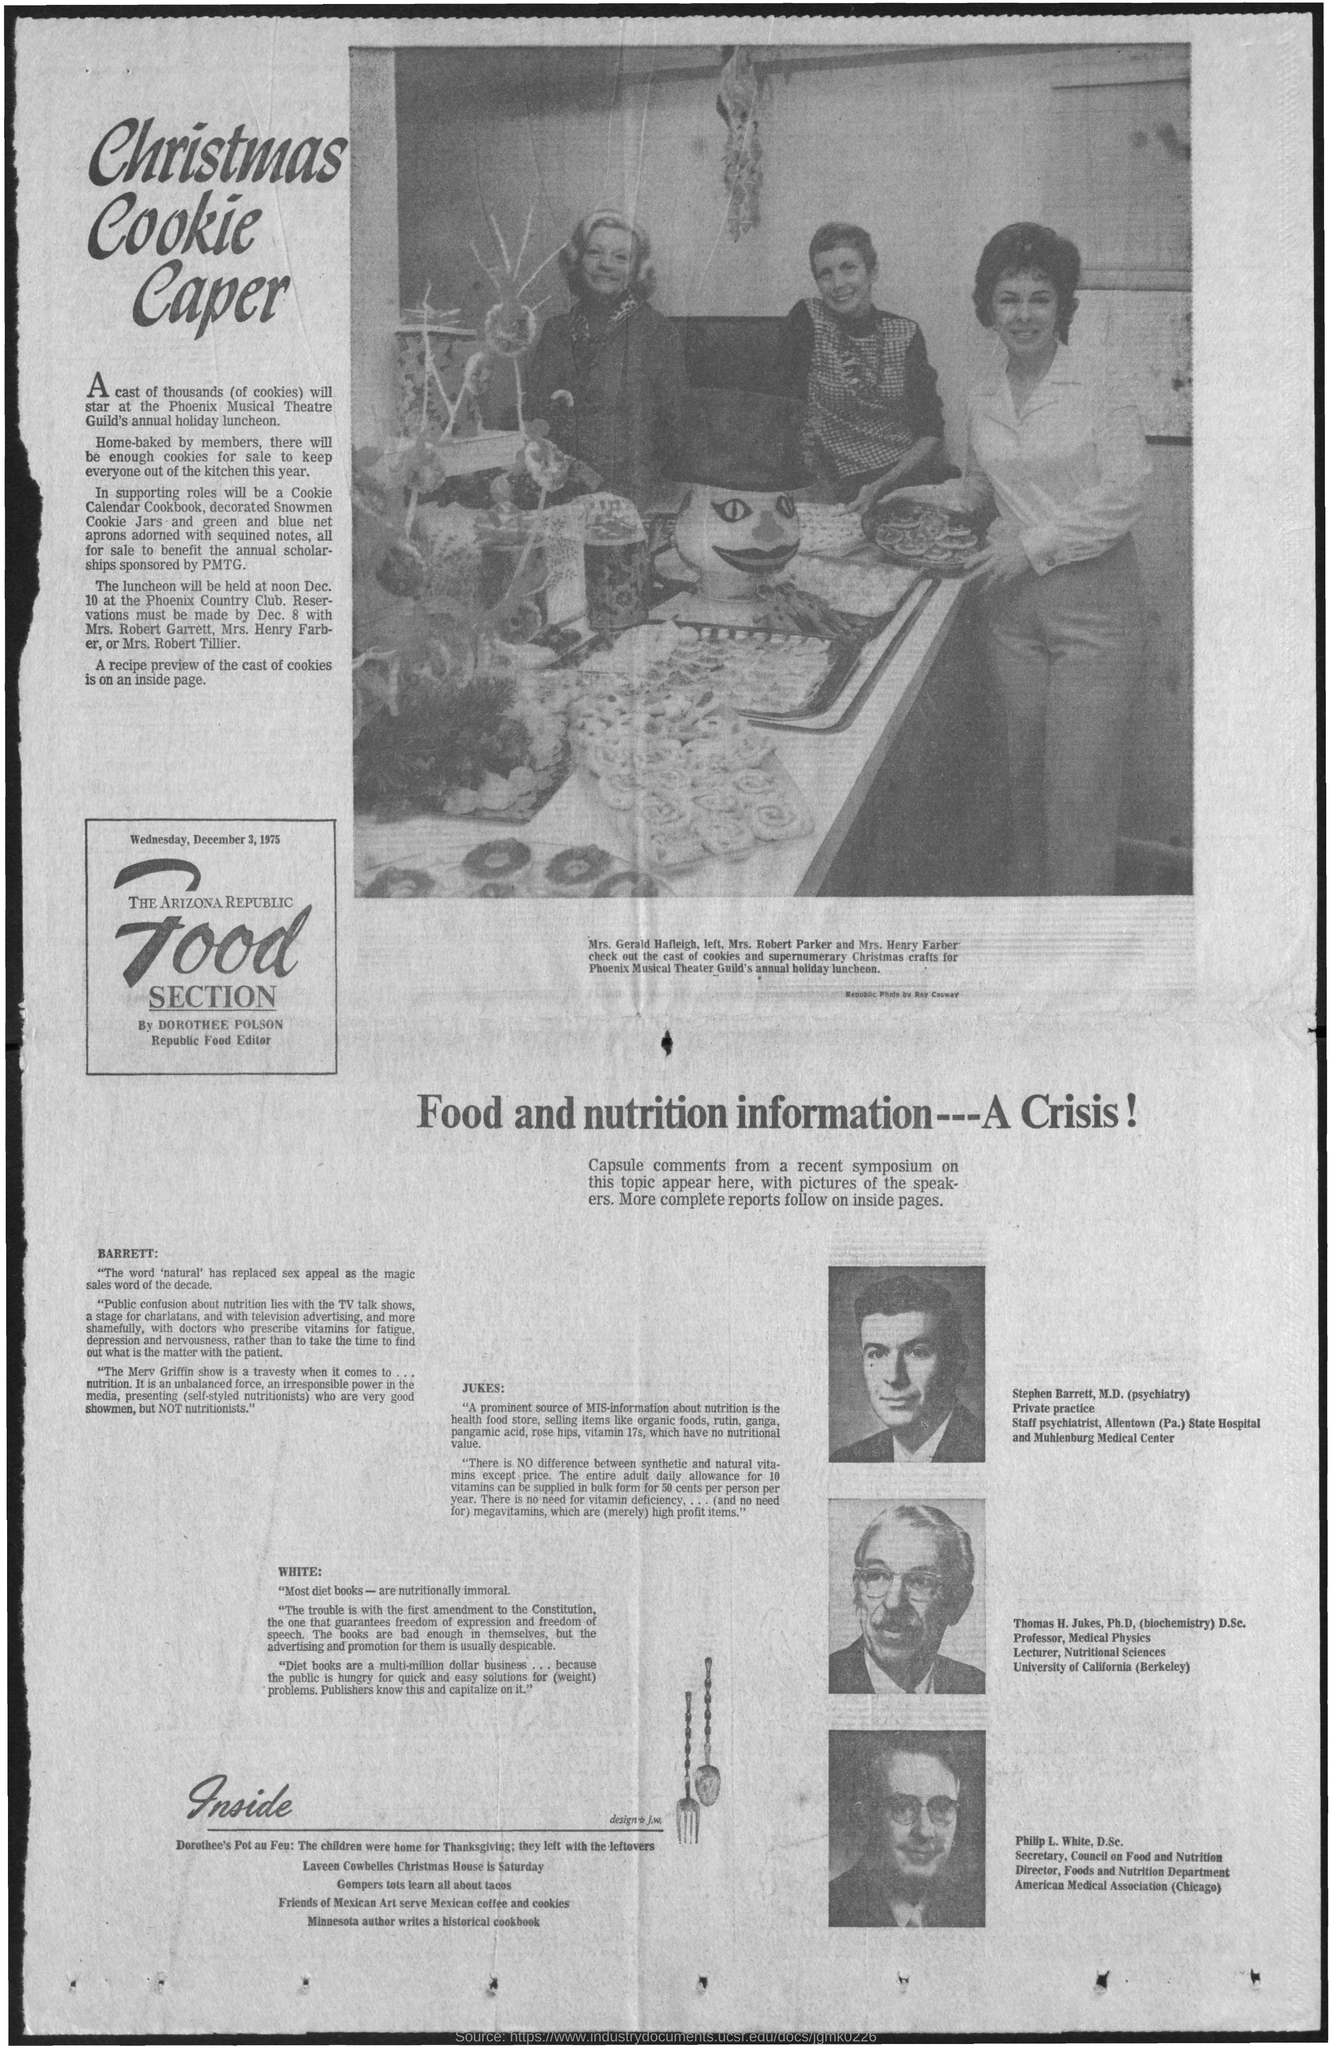Where was the Phoenix Musical Theatre Guild's annual holiday luncheon held?
Your answer should be very brief. Phoenix Country Club. When was the Phoenix Musical Theatre Guild's annual holiday luncheon held?
Offer a terse response. At noon dec. 10. 